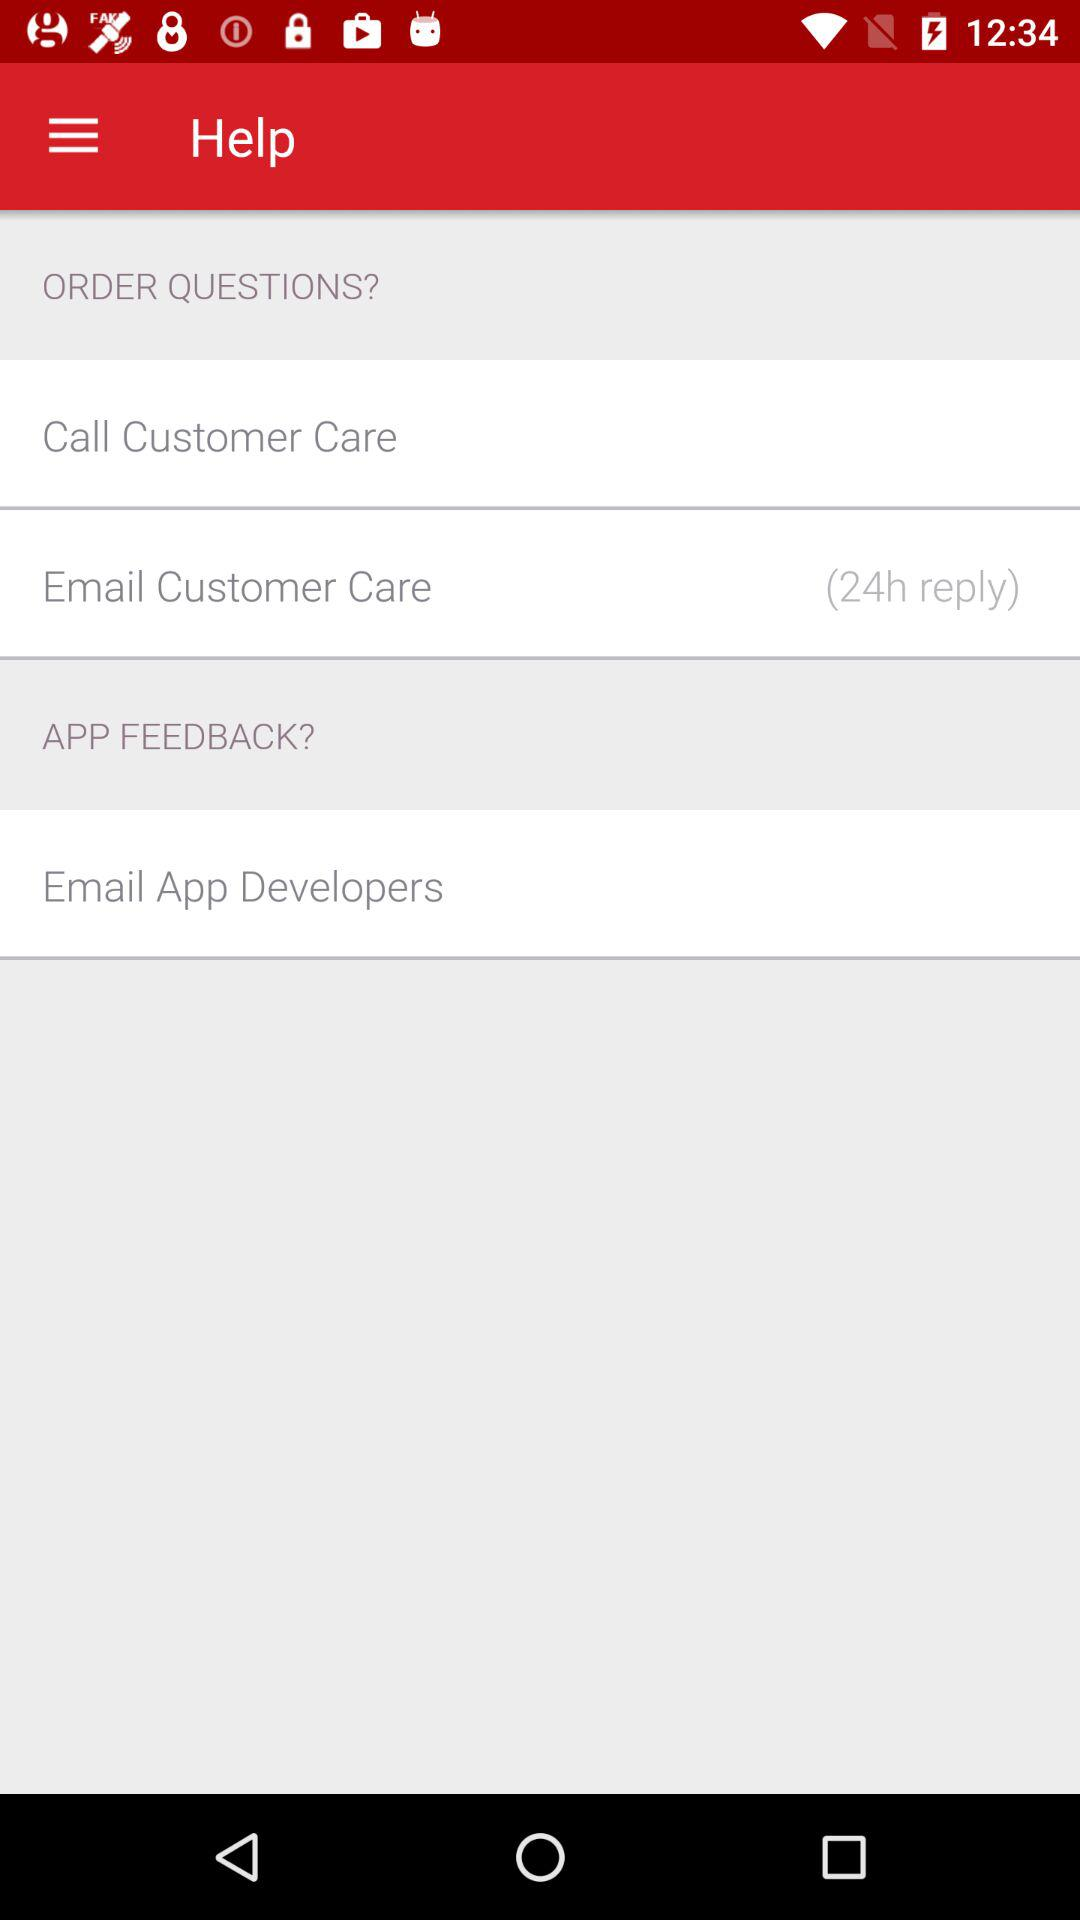How many reply to customer care emails shown hare?
When the provided information is insufficient, respond with <no answer>. <no answer> 